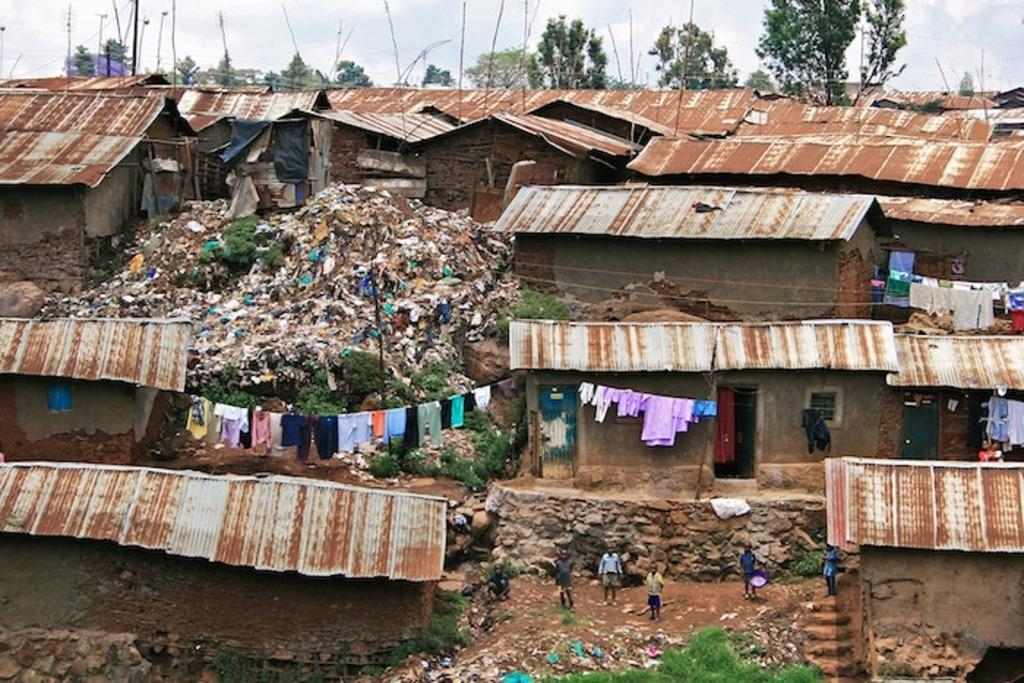What type of structures can be seen in the image? There are houses with roofs in the image. What are the people in the image doing? There are people standing in the image. What can be seen hanging on a rope in the image? Clothes are hanging on a rope in the image. What is visible in the image that might be considered waste? There is a garbage visible in the image. What type of natural elements are present in the image? Trees and plants are present in the image. How does the cannon grip the rope in the image? There is no cannon present in the image, so it cannot grip a rope. What type of government is depicted in the image? There is no depiction of a government in the image. 